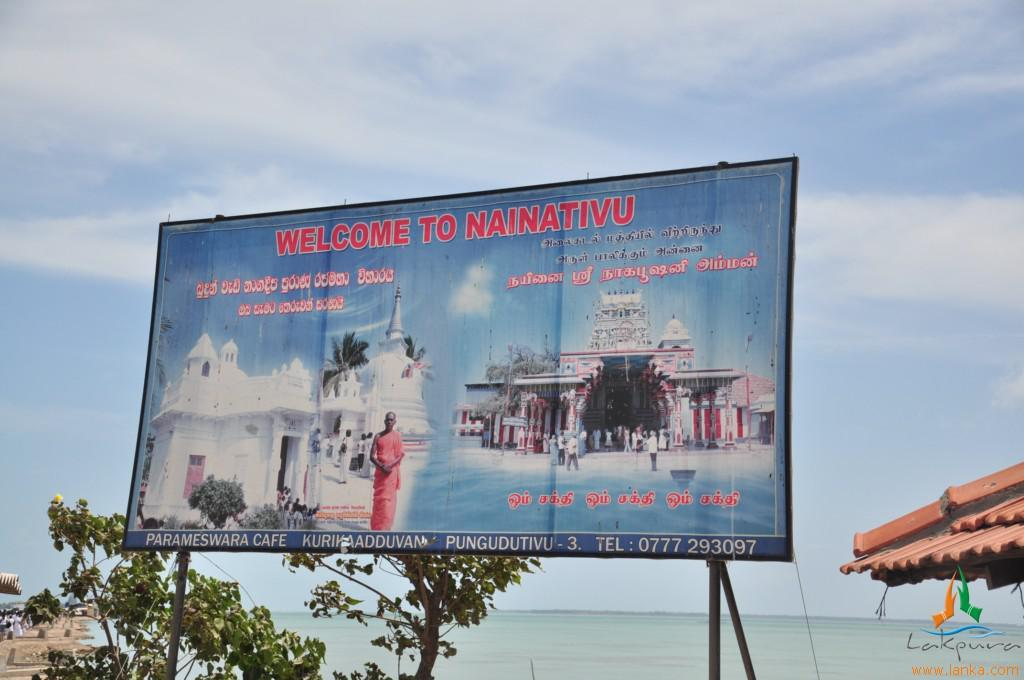<image>
Give a short and clear explanation of the subsequent image. welcome to naintivu street huge banner next to the beach 